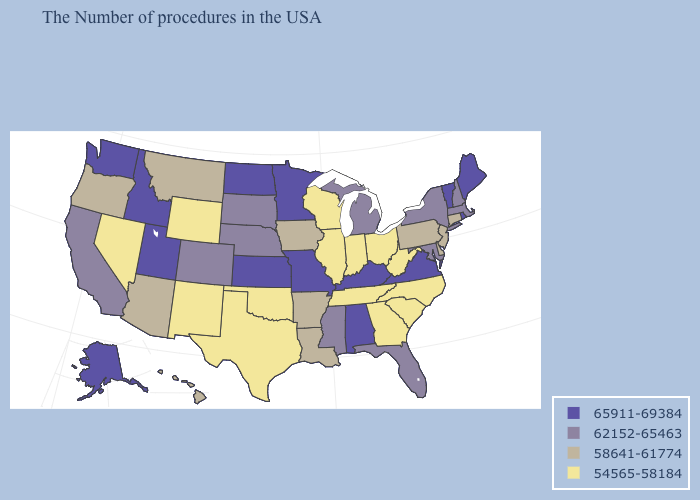What is the lowest value in the MidWest?
Answer briefly. 54565-58184. What is the value of Illinois?
Give a very brief answer. 54565-58184. Does Iowa have a lower value than Kentucky?
Concise answer only. Yes. Name the states that have a value in the range 58641-61774?
Short answer required. Connecticut, New Jersey, Delaware, Pennsylvania, Louisiana, Arkansas, Iowa, Montana, Arizona, Oregon, Hawaii. What is the highest value in states that border North Carolina?
Quick response, please. 65911-69384. What is the value of Rhode Island?
Keep it brief. 65911-69384. Does North Dakota have the highest value in the USA?
Quick response, please. Yes. Name the states that have a value in the range 58641-61774?
Write a very short answer. Connecticut, New Jersey, Delaware, Pennsylvania, Louisiana, Arkansas, Iowa, Montana, Arizona, Oregon, Hawaii. Does Missouri have the same value as Virginia?
Give a very brief answer. Yes. What is the lowest value in states that border Montana?
Concise answer only. 54565-58184. Which states have the lowest value in the South?
Answer briefly. North Carolina, South Carolina, West Virginia, Georgia, Tennessee, Oklahoma, Texas. What is the highest value in the USA?
Give a very brief answer. 65911-69384. What is the value of Iowa?
Keep it brief. 58641-61774. Does the first symbol in the legend represent the smallest category?
Write a very short answer. No. What is the lowest value in states that border Colorado?
Write a very short answer. 54565-58184. 